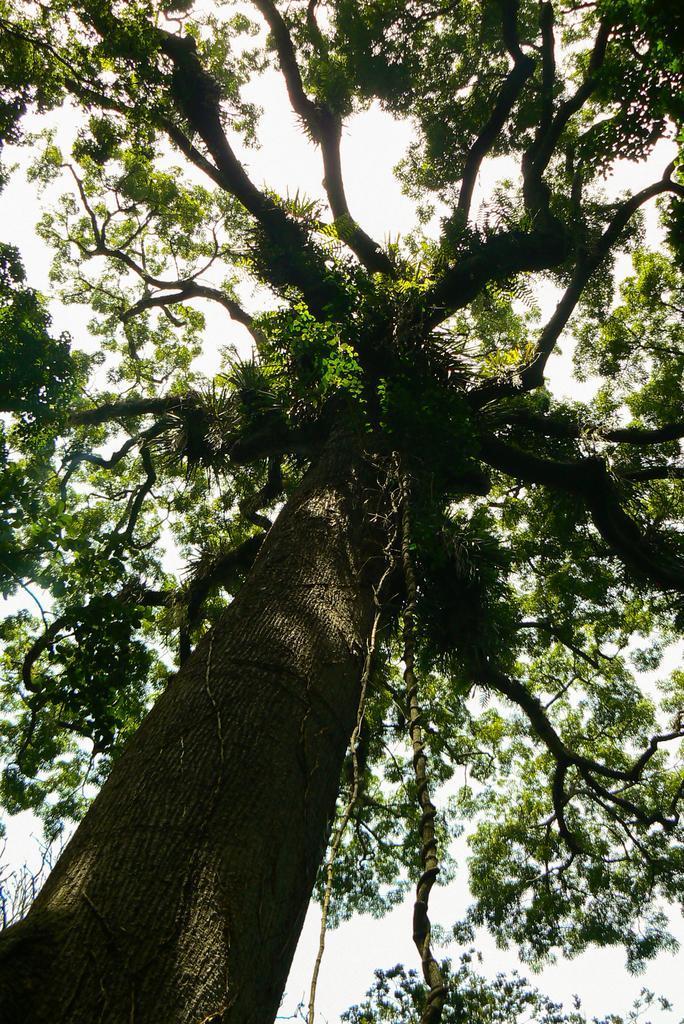In one or two sentences, can you explain what this image depicts? In this image we can see a tree and in the background we can see the sky. At the bottom we can see the branches of a tree. 